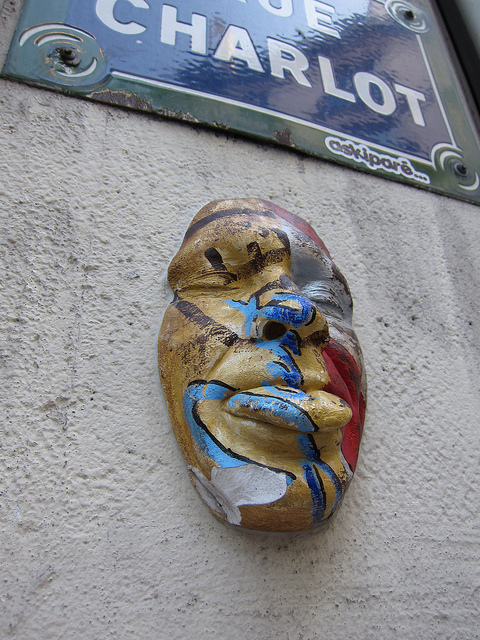Read all the text in this image. CHARLOT askipare 